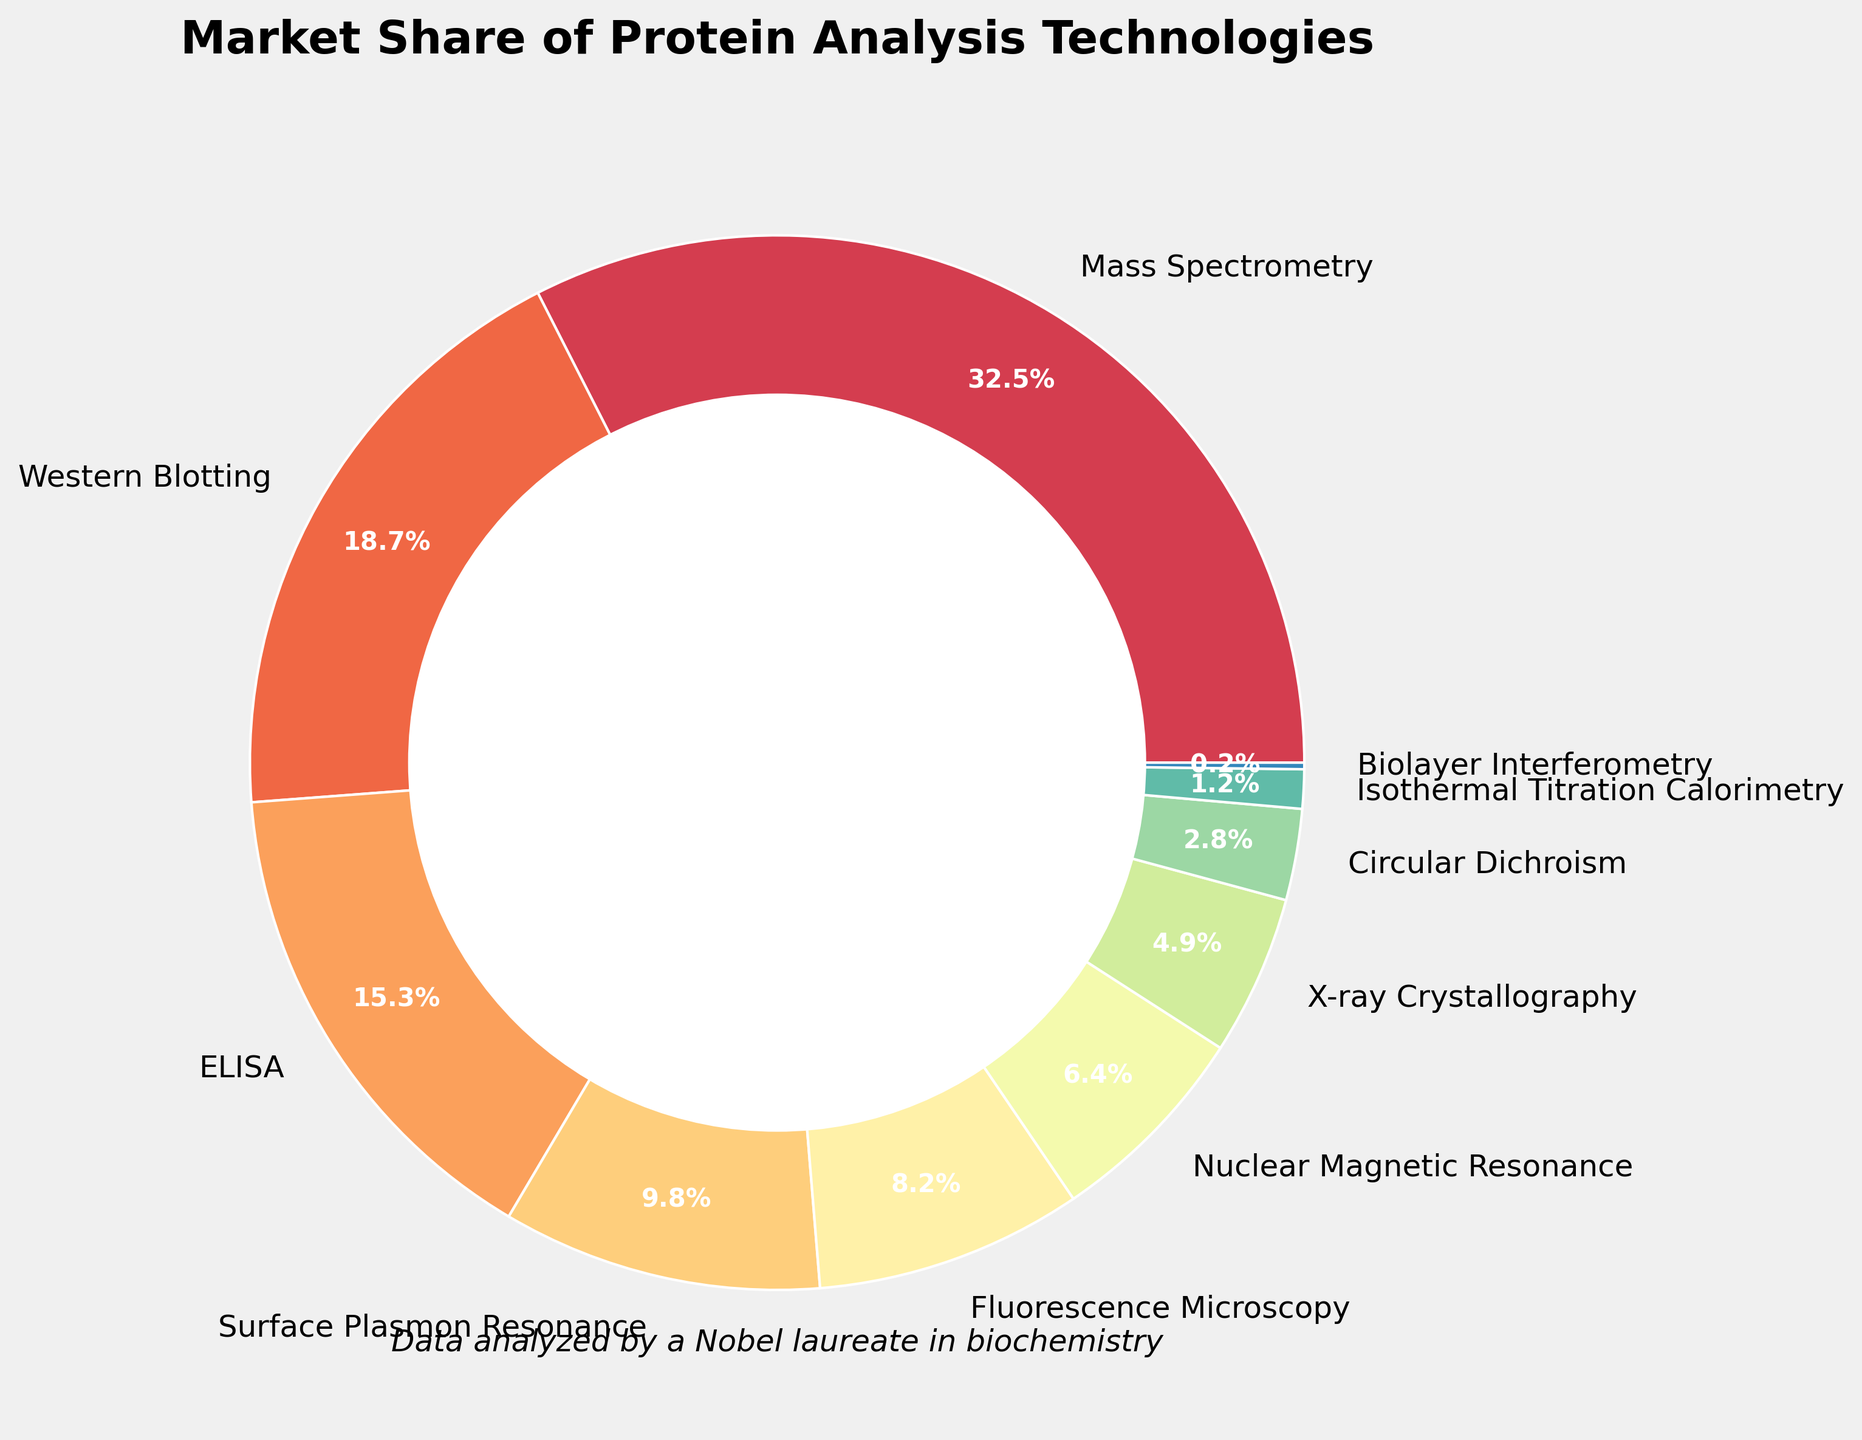Which technology has the highest market share? The pie chart shows that Mass Spectrometry has the largest segment, indicating its market share is the highest among the listed technologies.
Answer: Mass Spectrometry What is the combined market share of Western Blotting and ELISA? According to the figure, Western Blotting has a market share of 18.7% and ELISA has 15.3%. Adding these together: 18.7 + 15.3 = 34.0%.
Answer: 34.0% How much more market share does Mass Spectrometry have compared to Surface Plasmon Resonance? The market share of Mass Spectrometry is 32.5%, and Surface Plasmon Resonance is 9.8%. The difference is 32.5 - 9.8 = 22.7%.
Answer: 22.7% Which technology has the smallest market share, and what is it? The pie chart shows that Biolayer Interferometry has the smallest segment, indicating the smallest market share of 0.2%.
Answer: Biolayer Interferometry, 0.2% What's the combined market share of Nuclear Magnetic Resonance and X-ray Crystallography? According to the chart, Nuclear Magnetic Resonance has a market share of 6.4%, and X-ray Crystallography has 4.9%. Adding these together: 6.4 + 4.9 = 11.3%.
Answer: 11.3% How much less market share does Fluorescence Microscopy have compared to Western Blotting? The market share of Western Blotting is 18.7%, and Fluorescence Microscopy is 8.2%. The difference is 18.7 - 8.2 = 10.5%.
Answer: 10.5% Which technology has a market share closest to 5%? The pie chart shows that X-ray Crystallography has a market share of 4.9%, which is closest to 5%.
Answer: X-ray Crystallography What is the difference between the market share of the technology with the highest share and the technology with the second highest share? The highest market share is Mass Spectrometry at 32.5%, and the second highest is Western Blotting at 18.7%. The difference is 32.5 - 18.7 = 13.8%.
Answer: 13.8% Which technology has a market share greater than 10% but less than 20%? Western Blotting at 18.7% and ELISA at 15.3% are the only technologies that fall within this range.
Answer: Western Blotting, ELISA 